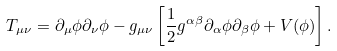<formula> <loc_0><loc_0><loc_500><loc_500>T _ { \mu \nu } = \partial _ { \mu } \phi \partial _ { \nu } \phi - g _ { \mu \nu } \left [ \frac { 1 } { 2 } g ^ { \alpha \beta } \partial _ { \alpha } \phi \partial _ { \beta } \phi + V ( \phi ) \right ] .</formula> 